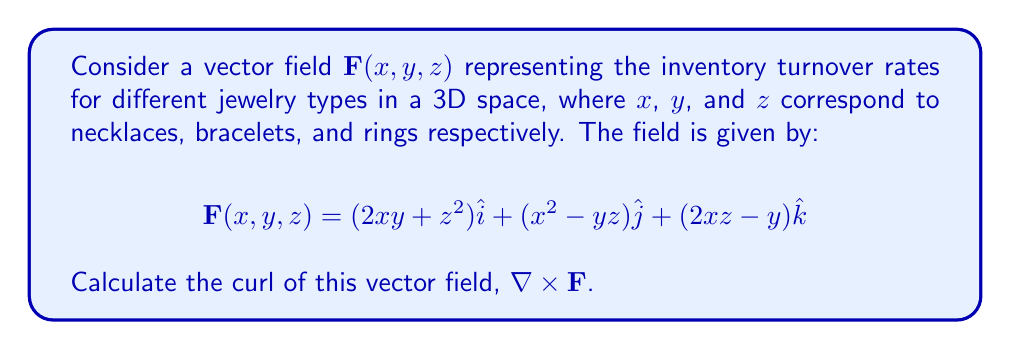Can you solve this math problem? To find the curl of the vector field, we need to calculate:

$$\nabla \times \mathbf{F} = \left(\frac{\partial F_z}{\partial y} - \frac{\partial F_y}{\partial z}\right)\hat{i} + \left(\frac{\partial F_x}{\partial z} - \frac{\partial F_z}{\partial x}\right)\hat{j} + \left(\frac{\partial F_y}{\partial x} - \frac{\partial F_x}{\partial y}\right)\hat{k}$$

Let's calculate each component:

1. $\hat{i}$ component:
   $\frac{\partial F_z}{\partial y} = -1$
   $\frac{\partial F_y}{\partial z} = -y$
   $\frac{\partial F_z}{\partial y} - \frac{\partial F_y}{\partial z} = -1 - (-y) = y - 1$

2. $\hat{j}$ component:
   $\frac{\partial F_x}{\partial z} = 2z$
   $\frac{\partial F_z}{\partial x} = 2z$
   $\frac{\partial F_x}{\partial z} - \frac{\partial F_z}{\partial x} = 2z - 2z = 0$

3. $\hat{k}$ component:
   $\frac{\partial F_y}{\partial x} = 2x$
   $\frac{\partial F_x}{\partial y} = 2x$
   $\frac{\partial F_y}{\partial x} - \frac{\partial F_x}{\partial y} = 2x - 2x = 0$

Combining these results, we get:

$$\nabla \times \mathbf{F} = (y - 1)\hat{i} + 0\hat{j} + 0\hat{k}$$
Answer: $(y - 1)\hat{i}$ 